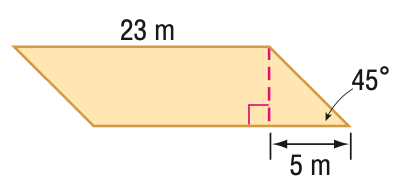Answer the mathemtical geometry problem and directly provide the correct option letter.
Question: Find the perimeter of the parallelogram. Round to the nearest tenth if necessary.
Choices: A: 53.1 B: 56 C: 60.1 D: 63.3 C 